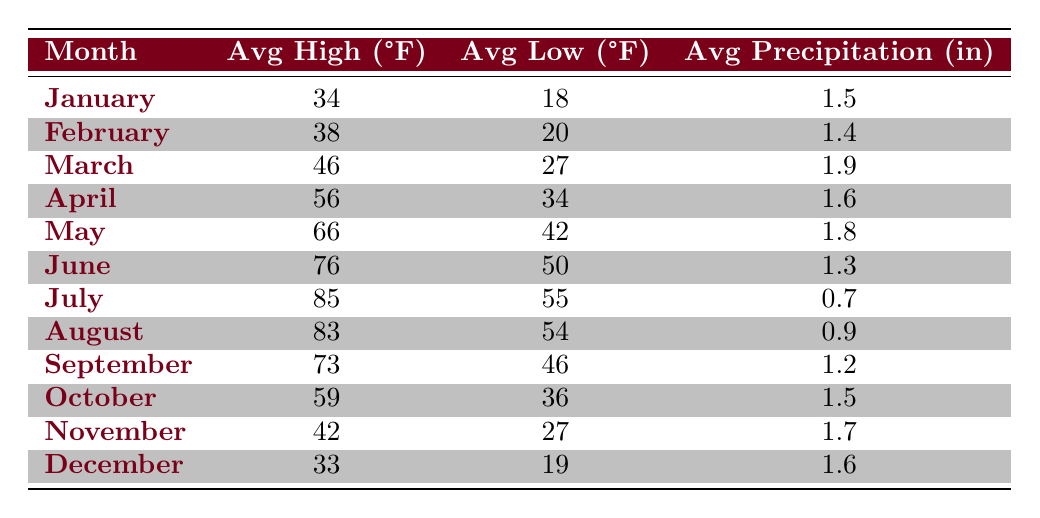What is the average high temperature in July? The data shows that the average high temperature in July is 85°F.
Answer: 85°F What month has the highest average low temperature? By examining the table, July has the highest average low temperature of 55°F.
Answer: 55°F What is the average precipitation in May? The table indicates that the average precipitation in May is 1.8 inches.
Answer: 1.8 inches Which month has the lowest average high temperature? Looking at the table, January has the lowest average high temperature at 34°F.
Answer: 34°F What is the difference in average high temperature between July and January? The average high in July is 85°F and in January is 34°F. The difference is 85 - 34 = 51°F.
Answer: 51°F What is the average low temperature for the months of June and July? The average low in June is 50°F and in July is 55°F. The average of these two values is (50 + 55) / 2 = 52.5°F.
Answer: 52.5°F Does December have a higher average precipitation than February? December's average precipitation is 1.6 inches while February's is 1.4 inches. Since 1.6 > 1.4, December does have higher precipitation.
Answer: Yes What is the total average precipitation for the summer months? The summer months are June (1.3), July (0.7), and August (0.9) inches. Summing these values gives 1.3 + 0.7 + 0.9 = 2.9 inches.
Answer: 2.9 inches What is the monthly average low temperature for the first half of the year? The first half includes January (18), February (20), March (27), April (34), May (42), and June (50). HThe average of these values is (18 + 20 + 27 + 34 + 42 + 50) / 6 = 31.17°F.
Answer: 31.17°F Which month has the highest precipitation and how much? March has the highest average precipitation at 1.9 inches according to the table.
Answer: 1.9 inches Is the average low temperature in November higher than in January? November's average low is 27°F and January's is 18°F. Since 27 > 18, November has a higher average low.
Answer: Yes 